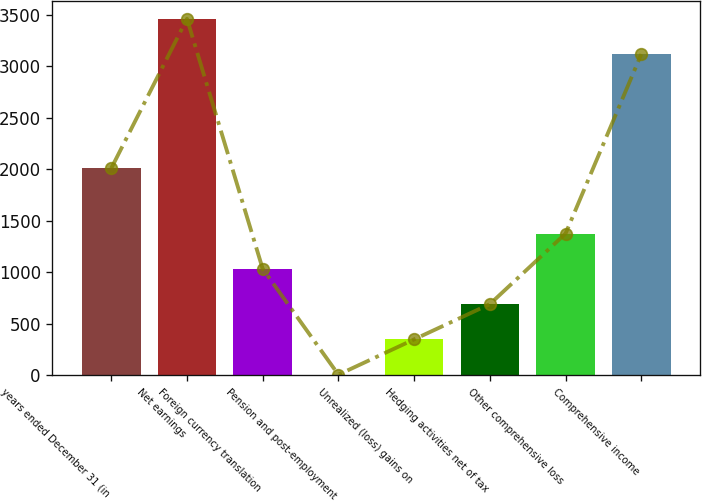Convert chart. <chart><loc_0><loc_0><loc_500><loc_500><bar_chart><fcel>years ended December 31 (in<fcel>Net earnings<fcel>Foreign currency translation<fcel>Pension and post-employment<fcel>Unrealized (loss) gains on<fcel>Hedging activities net of tax<fcel>Other comprehensive loss<fcel>Comprehensive income<nl><fcel>2011<fcel>3462.6<fcel>1034.8<fcel>7<fcel>349.6<fcel>692.2<fcel>1377.4<fcel>3120<nl></chart> 